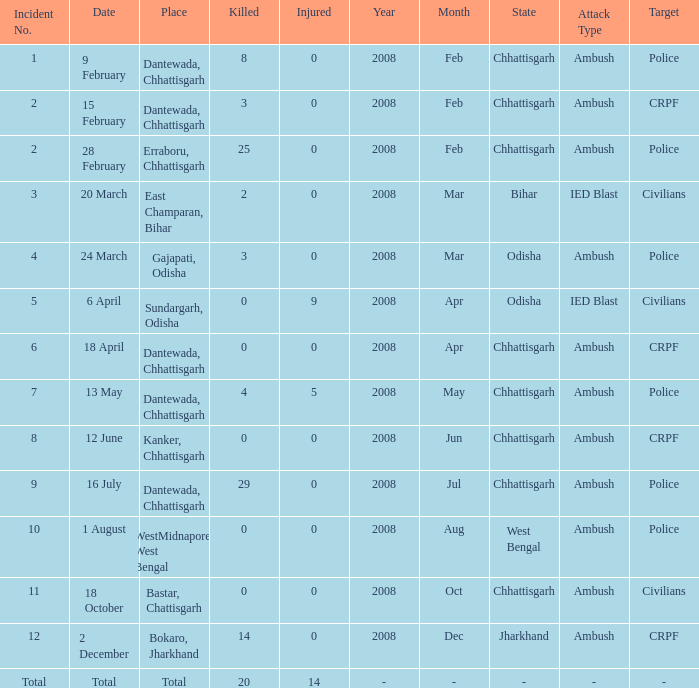What is the least amount of injuries in Dantewada, Chhattisgarh when 8 people were killed? 0.0. Write the full table. {'header': ['Incident No.', 'Date', 'Place', 'Killed', 'Injured', 'Year', 'Month', 'State', 'Attack Type', 'Target'], 'rows': [['1', '9 February', 'Dantewada, Chhattisgarh', '8', '0', '2008', 'Feb', 'Chhattisgarh', 'Ambush', 'Police'], ['2', '15 February', 'Dantewada, Chhattisgarh', '3', '0', '2008', 'Feb', 'Chhattisgarh', 'Ambush', 'CRPF'], ['2', '28 February', 'Erraboru, Chhattisgarh', '25', '0', '2008', 'Feb', 'Chhattisgarh', 'Ambush', 'Police'], ['3', '20 March', 'East Champaran, Bihar', '2', '0', '2008', 'Mar', 'Bihar', 'IED Blast', 'Civilians'], ['4', '24 March', 'Gajapati, Odisha', '3', '0', '2008', 'Mar', 'Odisha', 'Ambush', 'Police'], ['5', '6 April', 'Sundargarh, Odisha', '0', '9', '2008', 'Apr', 'Odisha', 'IED Blast', 'Civilians'], ['6', '18 April', 'Dantewada, Chhattisgarh', '0', '0', '2008', 'Apr', 'Chhattisgarh', 'Ambush', 'CRPF'], ['7', '13 May', 'Dantewada, Chhattisgarh', '4', '5', '2008', 'May', 'Chhattisgarh', 'Ambush', 'Police'], ['8', '12 June', 'Kanker, Chhattisgarh', '0', '0', '2008', 'Jun', 'Chhattisgarh', 'Ambush', 'CRPF'], ['9', '16 July', 'Dantewada, Chhattisgarh', '29', '0', '2008', 'Jul', 'Chhattisgarh', 'Ambush', 'Police'], ['10', '1 August', 'WestMidnapore, West Bengal', '0', '0', '2008', 'Aug', 'West Bengal', 'Ambush', 'Police'], ['11', '18 October', 'Bastar, Chattisgarh', '0', '0', '2008', 'Oct', 'Chhattisgarh', 'Ambush', 'Civilians'], ['12', '2 December', 'Bokaro, Jharkhand', '14', '0', '2008', 'Dec', 'Jharkhand', 'Ambush', 'CRPF'], ['Total', 'Total', 'Total', '20', '14', '-', '-', '-', '-', '-']]} 